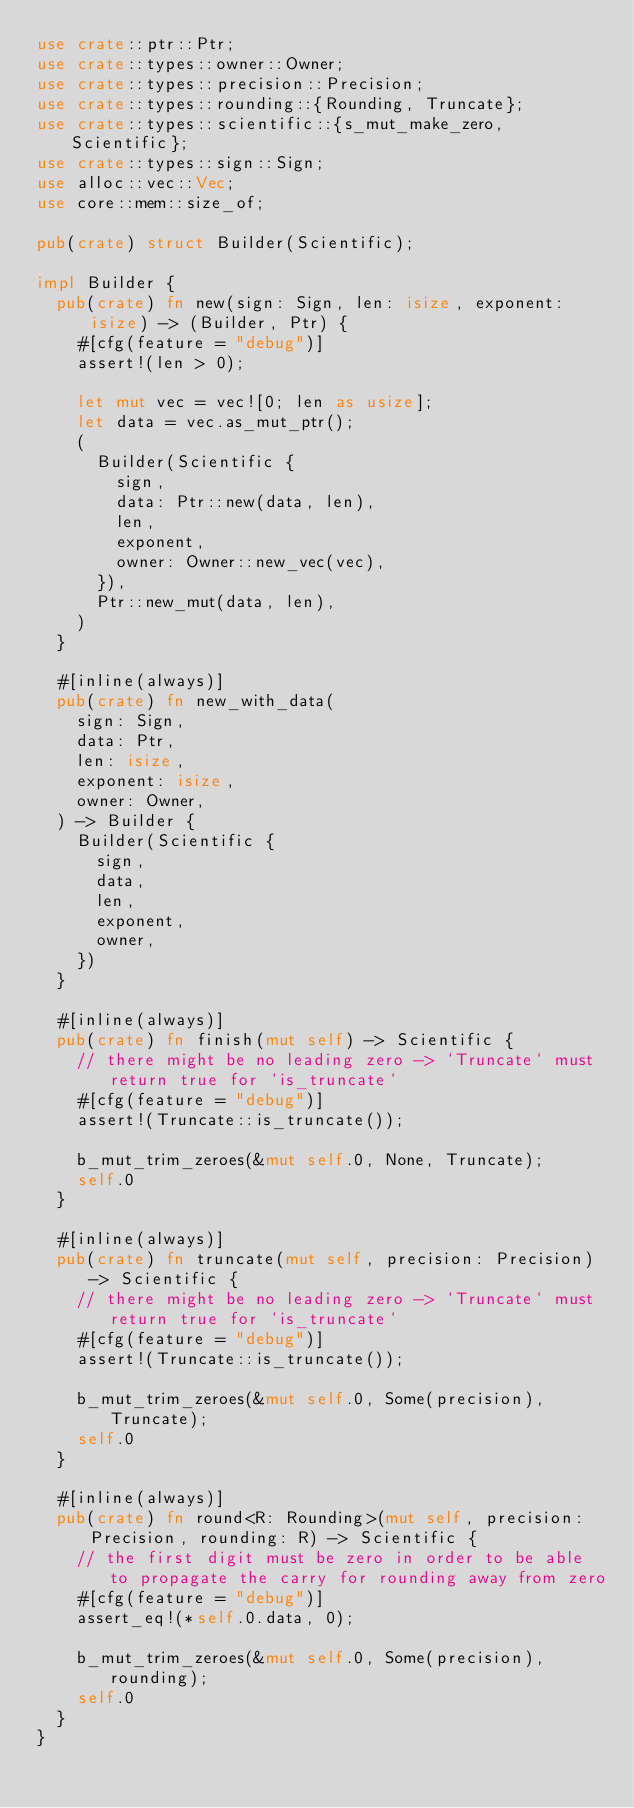Convert code to text. <code><loc_0><loc_0><loc_500><loc_500><_Rust_>use crate::ptr::Ptr;
use crate::types::owner::Owner;
use crate::types::precision::Precision;
use crate::types::rounding::{Rounding, Truncate};
use crate::types::scientific::{s_mut_make_zero, Scientific};
use crate::types::sign::Sign;
use alloc::vec::Vec;
use core::mem::size_of;

pub(crate) struct Builder(Scientific);

impl Builder {
  pub(crate) fn new(sign: Sign, len: isize, exponent: isize) -> (Builder, Ptr) {
    #[cfg(feature = "debug")]
    assert!(len > 0);

    let mut vec = vec![0; len as usize];
    let data = vec.as_mut_ptr();
    (
      Builder(Scientific {
        sign,
        data: Ptr::new(data, len),
        len,
        exponent,
        owner: Owner::new_vec(vec),
      }),
      Ptr::new_mut(data, len),
    )
  }

  #[inline(always)]
  pub(crate) fn new_with_data(
    sign: Sign,
    data: Ptr,
    len: isize,
    exponent: isize,
    owner: Owner,
  ) -> Builder {
    Builder(Scientific {
      sign,
      data,
      len,
      exponent,
      owner,
    })
  }

  #[inline(always)]
  pub(crate) fn finish(mut self) -> Scientific {
    // there might be no leading zero -> `Truncate` must return true for `is_truncate`
    #[cfg(feature = "debug")]
    assert!(Truncate::is_truncate());

    b_mut_trim_zeroes(&mut self.0, None, Truncate);
    self.0
  }

  #[inline(always)]
  pub(crate) fn truncate(mut self, precision: Precision) -> Scientific {
    // there might be no leading zero -> `Truncate` must return true for `is_truncate`
    #[cfg(feature = "debug")]
    assert!(Truncate::is_truncate());

    b_mut_trim_zeroes(&mut self.0, Some(precision), Truncate);
    self.0
  }

  #[inline(always)]
  pub(crate) fn round<R: Rounding>(mut self, precision: Precision, rounding: R) -> Scientific {
    // the first digit must be zero in order to be able to propagate the carry for rounding away from zero
    #[cfg(feature = "debug")]
    assert_eq!(*self.0.data, 0);

    b_mut_trim_zeroes(&mut self.0, Some(precision), rounding);
    self.0
  }
}
</code> 